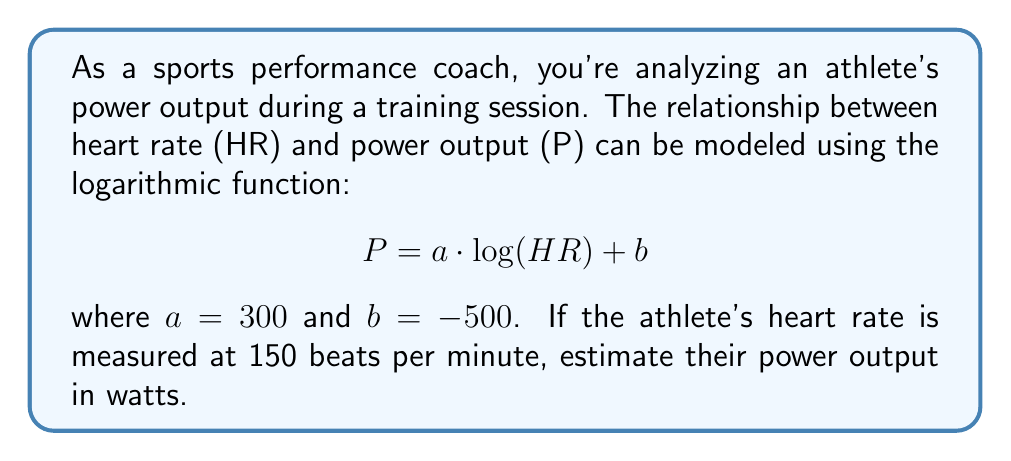Can you answer this question? To solve this problem, we'll follow these steps:

1) We're given the logarithmic function: $P = a \cdot \log(HR) + b$
   Where $a = 300$, $b = -500$, and $HR = 150$

2) Substitute the values into the equation:
   $P = 300 \cdot \log(150) - 500$

3) Calculate $\log(150)$:
   $\log(150) \approx 2.1761$ (using a calculator or logarithm table)

4) Multiply by 300:
   $300 \cdot 2.1761 \approx 652.83$

5) Subtract 500:
   $652.83 - 500 = 152.83$

6) Round to the nearest whole number, as power output is typically expressed in whole watts:
   $152.83 \approx 153$ watts

Therefore, the estimated power output of the athlete is 153 watts.
Answer: 153 watts 